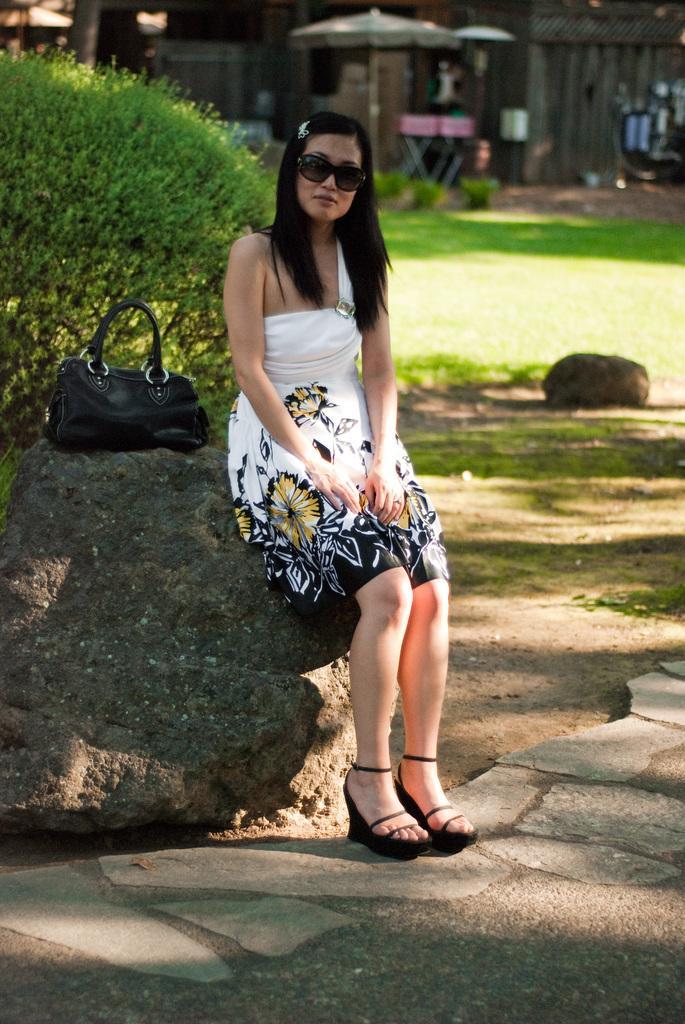Can you describe this image briefly? In this image I can see a woman wearing white, black and yellow colored dress and black colored goggles is sitting on a rock and I can see a bag on the rock which is black in color. In the background I can see some grass, a tree, a tent, few chairs and a building. 